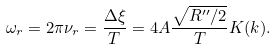<formula> <loc_0><loc_0><loc_500><loc_500>\omega _ { r } = 2 \pi \nu _ { r } = \frac { \Delta \xi } { T } = 4 A \frac { \sqrt { R ^ { \prime \prime } / 2 } } { T } K ( k ) .</formula> 